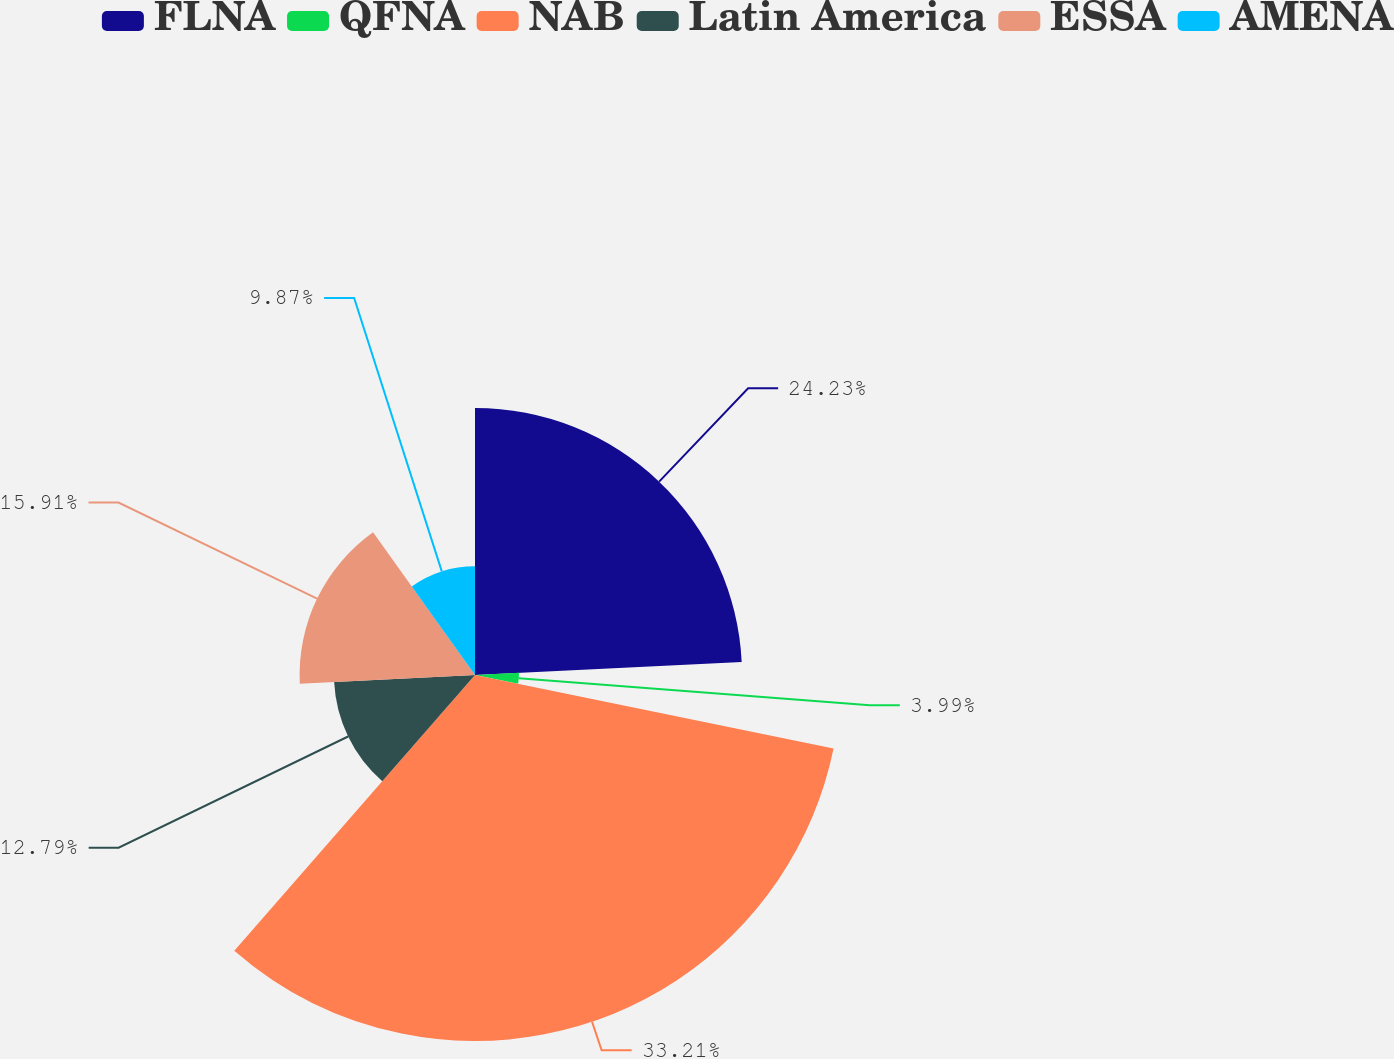Convert chart. <chart><loc_0><loc_0><loc_500><loc_500><pie_chart><fcel>FLNA<fcel>QFNA<fcel>NAB<fcel>Latin America<fcel>ESSA<fcel>AMENA<nl><fcel>24.22%<fcel>3.99%<fcel>33.2%<fcel>12.79%<fcel>15.91%<fcel>9.87%<nl></chart> 